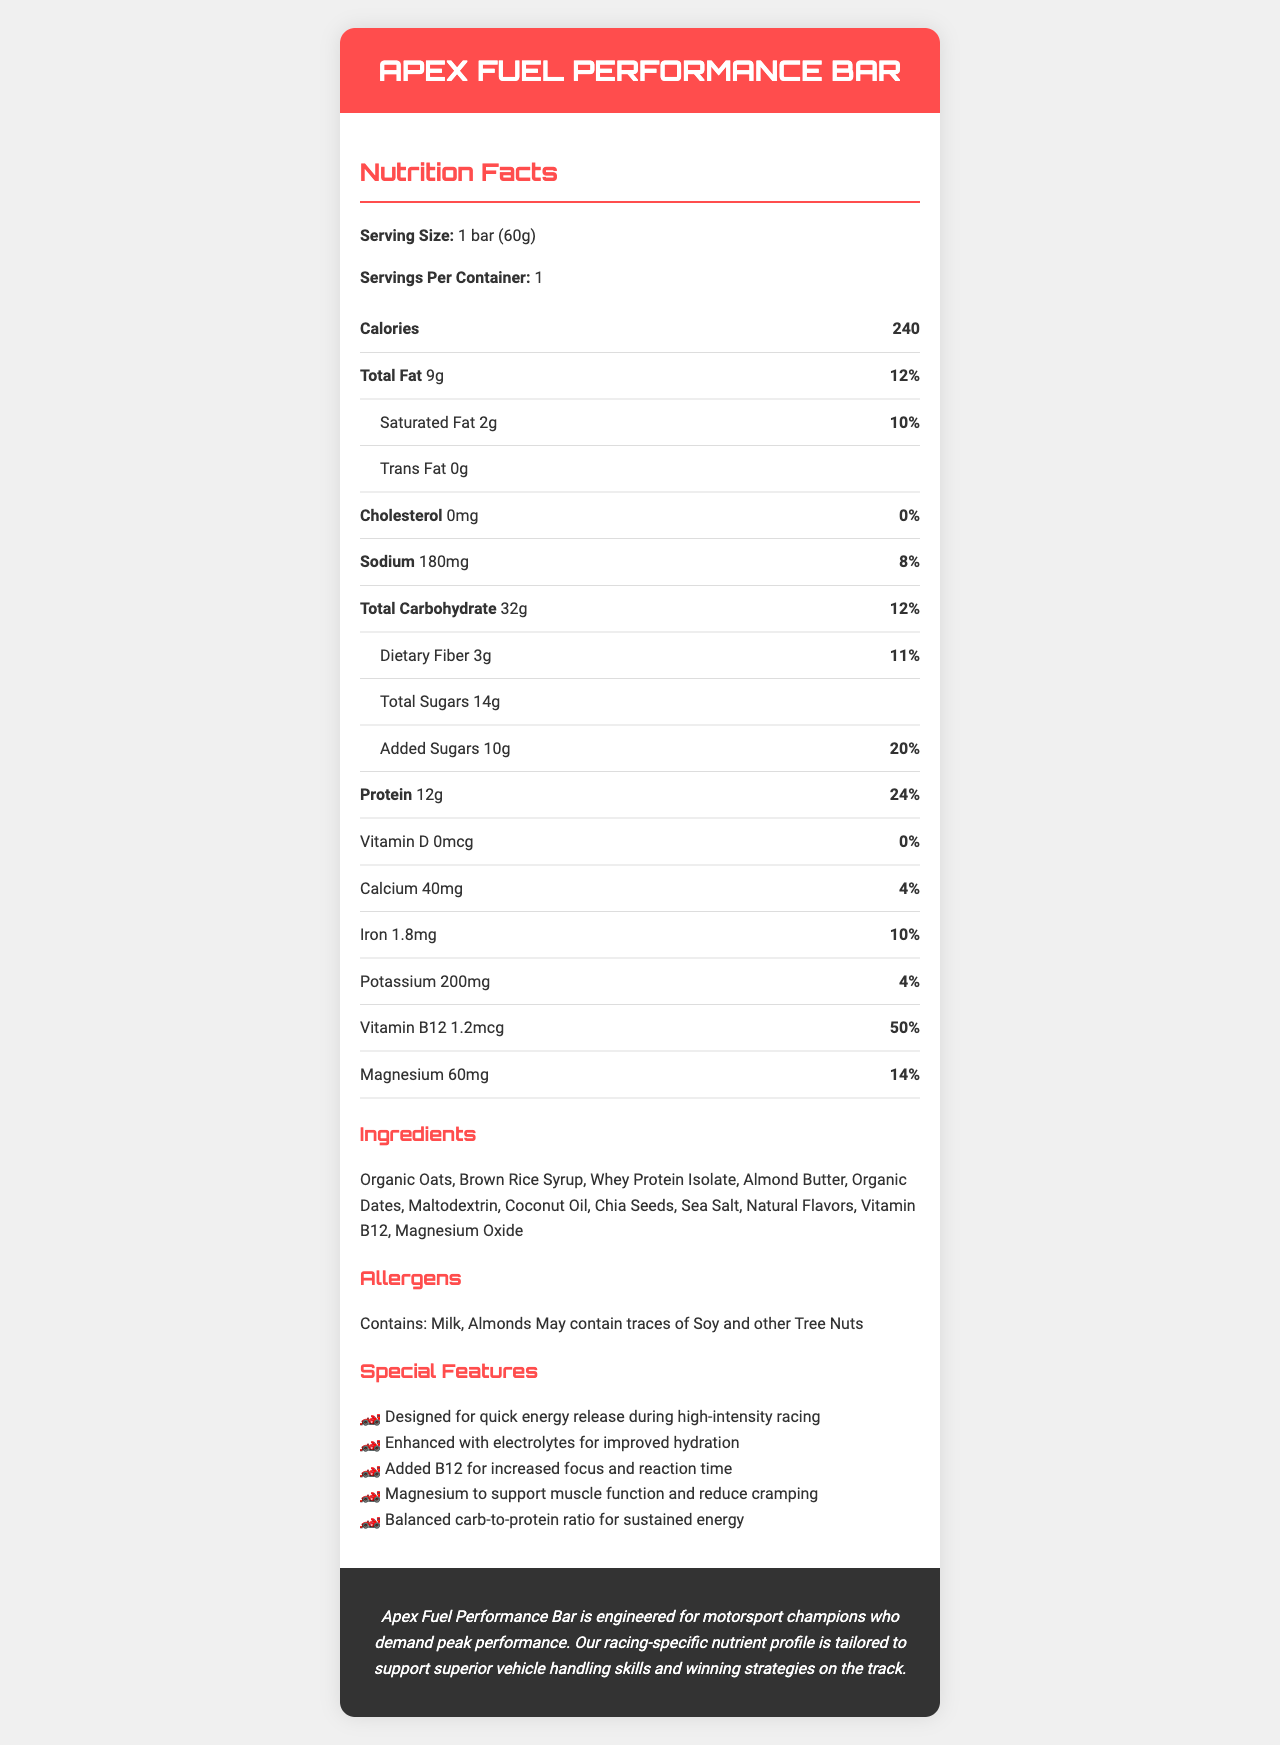what is the serving size of the Apex Fuel Performance Bar? The serving size is mentioned at the beginning of the Nutrition Facts section as "Serving Size: 1 bar (60g)".
Answer: 1 bar (60g) how many calories are in one serving? The calories per serving is listed as "Calories: 240" in the Nutrition Facts section.
Answer: 240 calories which ingredient is primarily responsible for the protein content in the bar? The ingredients list includes Whey Protein Isolate, which is a common protein source found in performance bars.
Answer: Whey Protein Isolate how much sodium does one serving contain? The sodium content for one serving is detailed as "Sodium: 180 mg" in the Nutrition Facts section.
Answer: 180mg what is the percentage of the daily value of vitamin B12 per serving? The daily value percentage for Vitamin B12 is given as "Vitamin B12: 50%" in the Nutrition Facts section.
Answer: 50% how much dietary fiber does the Apex Fuel Performance Bar provide per serving? The dietary fiber content is noted as "Dietary Fiber: 3g" in the Nutrition Facts.
Answer: 3g what is the primary benefit of the added B12 in the bar? One of the special features mentioned is "Added B12 for increased focus and reaction time."
Answer: Increased focus and reaction time which of the following is an allergen present in the bar? A. Peanuts B. Milk C. Wheat D. Shellfish The allergens list includes "Contains: Milk, Almonds."
Answer: B. Milk how much protein does one serving of the Apex Fuel Performance Bar contain? The protein content per serving is noted as "Protein: 12 g" in the Nutrition Facts section.
Answer: 12g is there any trans fat in the Apex Fuel Performance Bar? The document states "Trans Fat: 0 g", indicating there is no trans fat in the bar.
Answer: No summarize the main idea of the document. The document details the specific nutritional content per serving, highlights key ingredients, warns about potential allergens, outlines the benefits and special features for athletes, and includes a brand statement affirming the product's suitability for racing champions.
Answer: The document provides the nutrition facts, ingredients, allergens, special features, and a brand statement for the Apex Fuel Performance Bar, emphasizing its design for high-performance athletes, particularly in motorsports. does the bar contain any artificial flavors? The document lists "Natural Flavors" in the ingredients, but does not specify whether there are any artificial flavors.
Answer: Cannot be determined what is the total carbohydrate content of the bar? The total carbohydrate content is given as "Total Carbohydrate: 32 g" in the Nutrition Facts.
Answer: 32g which mineral in the bar supports muscle function and reduces cramping? A. Calcium B. Magnesium C. Potassium D. Iron The special features mention "Magnesium to support muscle function and reduce cramping."
Answer: B. Magnesium what is the special feature associated with electrolytes? One of the special features listed is "Enhanced with electrolytes for improved hydration."
Answer: Improved hydration are the sugars in the bar all natural? The document lists "Total Sugars: 14g," including "Added Sugars: 10g," indicating that not all sugars are naturally occurring.
Answer: No what is the daily value percentage for total fat in the bar? The daily value percentage for total fat is listed as "Total Fat: 12%".
Answer: 12% how many servings are in one container of the Apex Fuel Performance Bar? The servings per container is mentioned as "Servings Per Container: 1".
Answer: 1 what is the primary purpose of the Apex Fuel Performance Bar? The brand statement and special features emphasize its design for quick energy release and its suitability for high-intensity racing activities.
Answer: To provide quick energy release and support high-performance athletes during racing. 